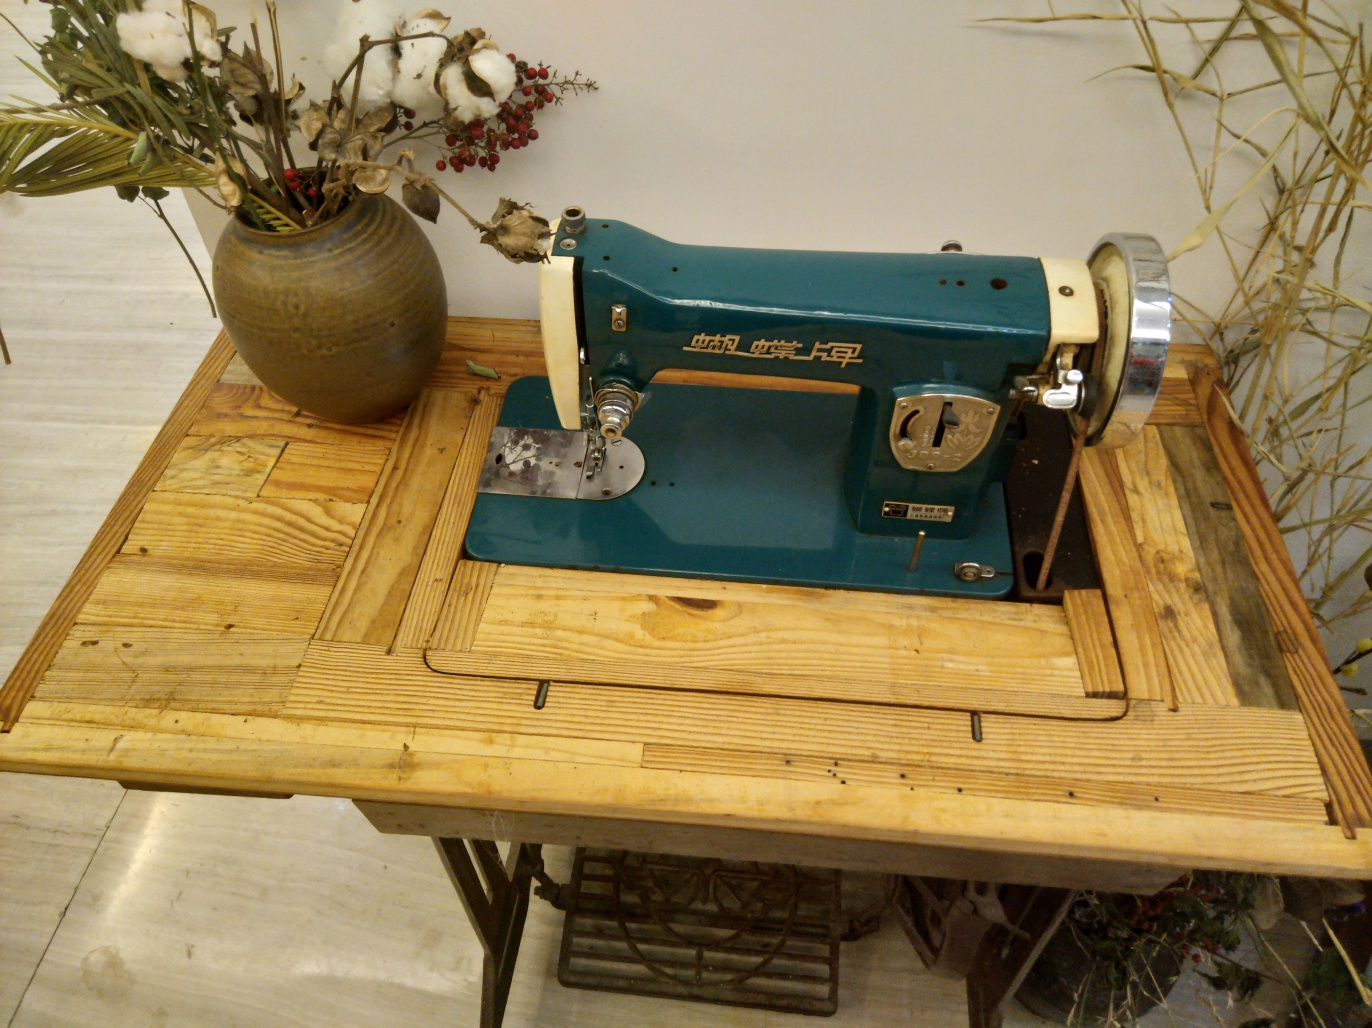How does the vintage sewing machine contribute to the overall atmosphere of this setting? The vintage sewing machine is a statement piece that exudes a sense of history and craftsmanship. Its presence, along with the natural elements and the wooden table, creates a charmingly nostalgic atmosphere that harks back to a bygone era of manual work and simplicity. 